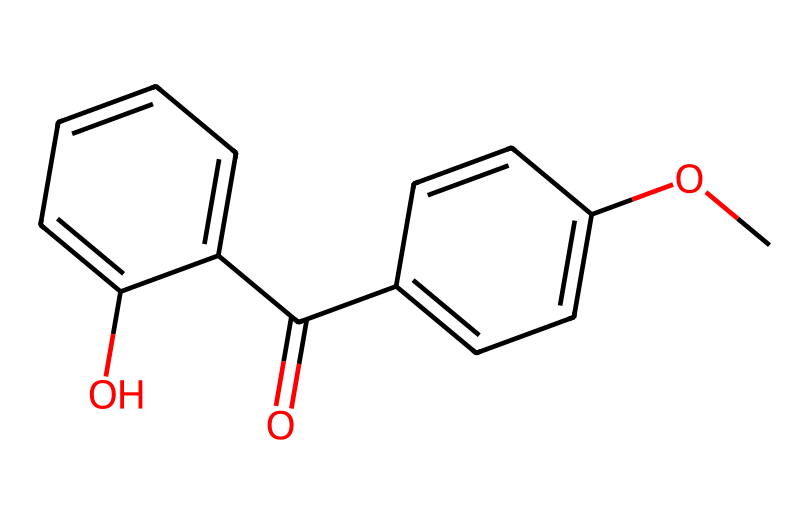What is the functional group present in this chemical? The chemical structure has a carbonyl group (C=O) indicated by the "O=C" at the beginning. This shows that it contains a ketone or an aldehyde functional group.
Answer: carbonyl How many rings are in this structure? By analyzing the structure, there are two benzene rings evident from the six-membered carbon cycles observed within the structure.
Answer: 2 What is the molecular formula of this compound? To deduce the molecular formula, count the carbon (C), hydrogen (H), and oxygen (O) atoms in the structure. In this case, there are 16 carbons, 14 hydrogens, and 3 oxygens. Thus, the formula is C16H14O3.
Answer: C16H14O3 Does this compound have any aromatic rings? The presence of double bonds in the cyclic structures and the continuous alternating double bonds confirm that this compound contains aromatic characteristics. The benzene rings are typical indicators of aromatic structures.
Answer: yes What type of sunscreen ingredient is this compound classified as? Based on its structure, particularly with the identified functional groups, this compound is often associated with being an UV filter ingredient in sunscreens due to its ability to absorb UV light.
Answer: UV filter 